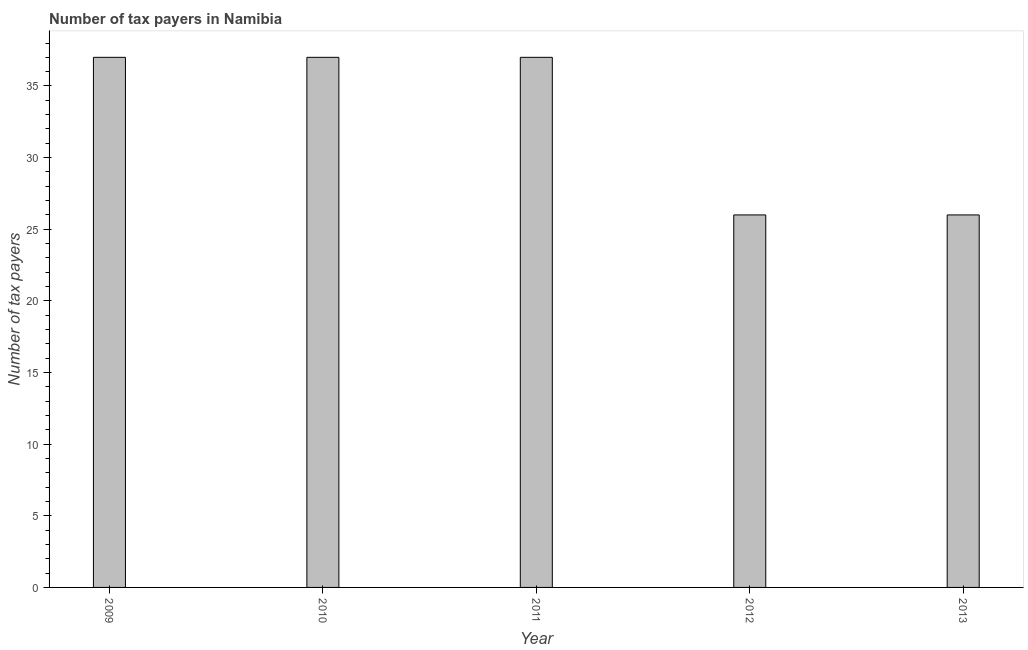What is the title of the graph?
Your answer should be compact. Number of tax payers in Namibia. What is the label or title of the Y-axis?
Your response must be concise. Number of tax payers. What is the number of tax payers in 2013?
Provide a short and direct response. 26. Across all years, what is the maximum number of tax payers?
Ensure brevity in your answer.  37. In which year was the number of tax payers minimum?
Give a very brief answer. 2012. What is the sum of the number of tax payers?
Provide a succinct answer. 163. What is the average number of tax payers per year?
Provide a short and direct response. 32. What is the median number of tax payers?
Provide a short and direct response. 37. Do a majority of the years between 2009 and 2013 (inclusive) have number of tax payers greater than 20 ?
Your response must be concise. Yes. Is the number of tax payers in 2010 less than that in 2013?
Give a very brief answer. No. What is the difference between the highest and the second highest number of tax payers?
Offer a very short reply. 0. What is the Number of tax payers in 2009?
Your answer should be very brief. 37. What is the Number of tax payers of 2011?
Your answer should be compact. 37. What is the difference between the Number of tax payers in 2009 and 2013?
Keep it short and to the point. 11. What is the difference between the Number of tax payers in 2010 and 2013?
Give a very brief answer. 11. What is the difference between the Number of tax payers in 2011 and 2013?
Your answer should be compact. 11. What is the ratio of the Number of tax payers in 2009 to that in 2010?
Provide a succinct answer. 1. What is the ratio of the Number of tax payers in 2009 to that in 2011?
Give a very brief answer. 1. What is the ratio of the Number of tax payers in 2009 to that in 2012?
Offer a terse response. 1.42. What is the ratio of the Number of tax payers in 2009 to that in 2013?
Ensure brevity in your answer.  1.42. What is the ratio of the Number of tax payers in 2010 to that in 2011?
Offer a terse response. 1. What is the ratio of the Number of tax payers in 2010 to that in 2012?
Provide a succinct answer. 1.42. What is the ratio of the Number of tax payers in 2010 to that in 2013?
Ensure brevity in your answer.  1.42. What is the ratio of the Number of tax payers in 2011 to that in 2012?
Your response must be concise. 1.42. What is the ratio of the Number of tax payers in 2011 to that in 2013?
Your answer should be very brief. 1.42. 